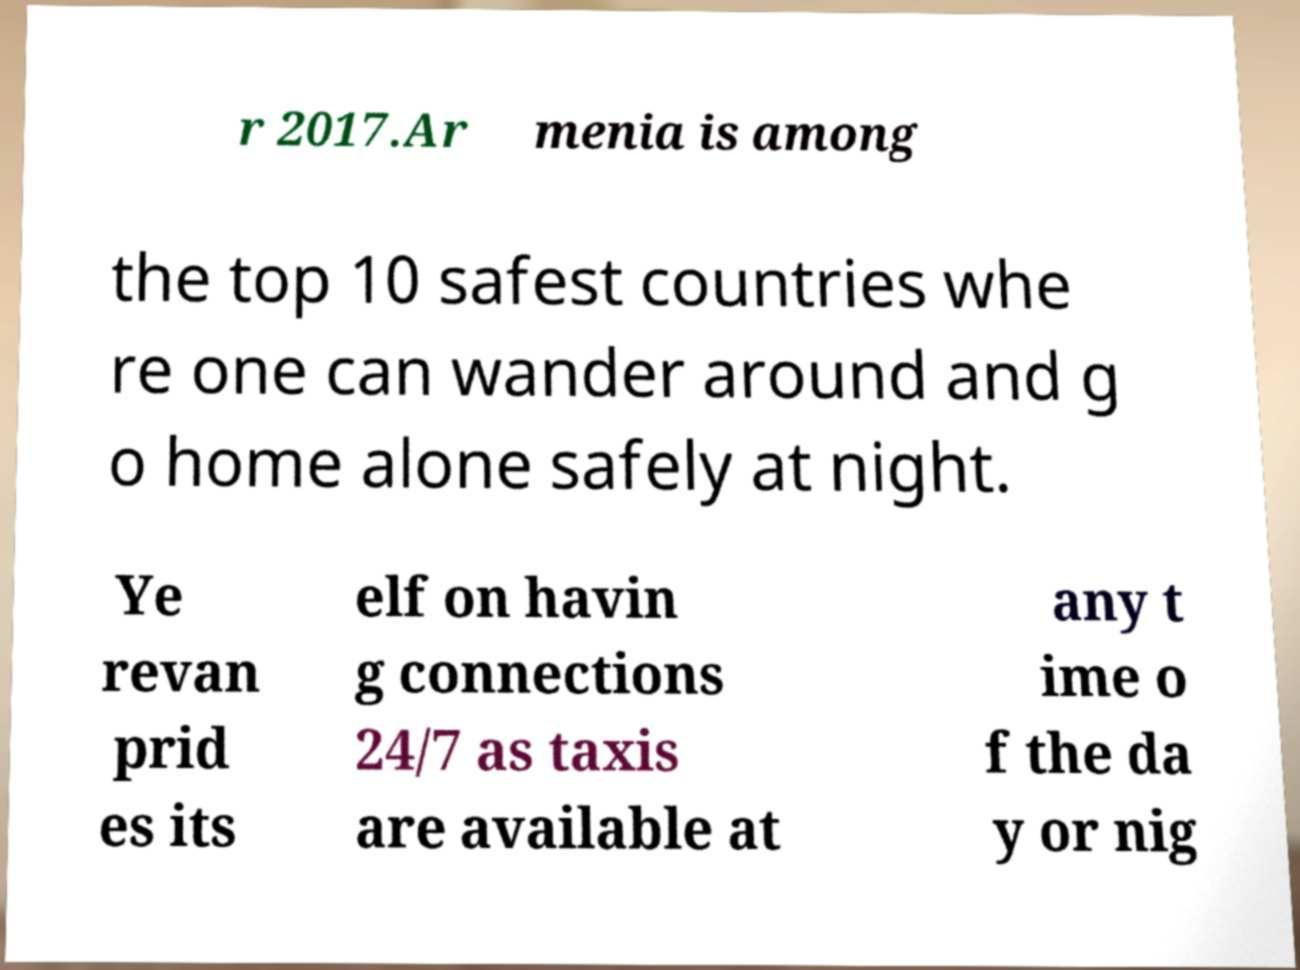Please identify and transcribe the text found in this image. r 2017.Ar menia is among the top 10 safest countries whe re one can wander around and g o home alone safely at night. Ye revan prid es its elf on havin g connections 24/7 as taxis are available at any t ime o f the da y or nig 